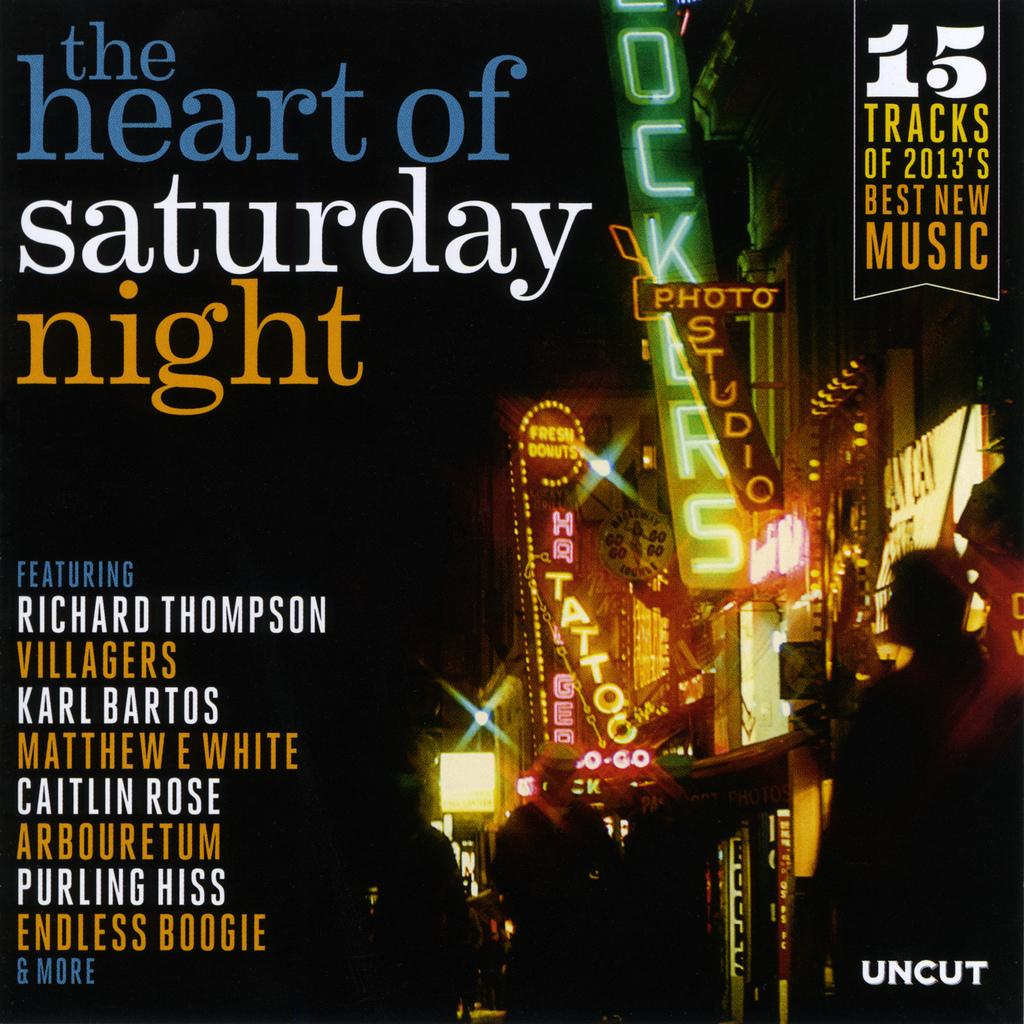<image>
Write a terse but informative summary of the picture. A magazine called the heart of saturday night. 